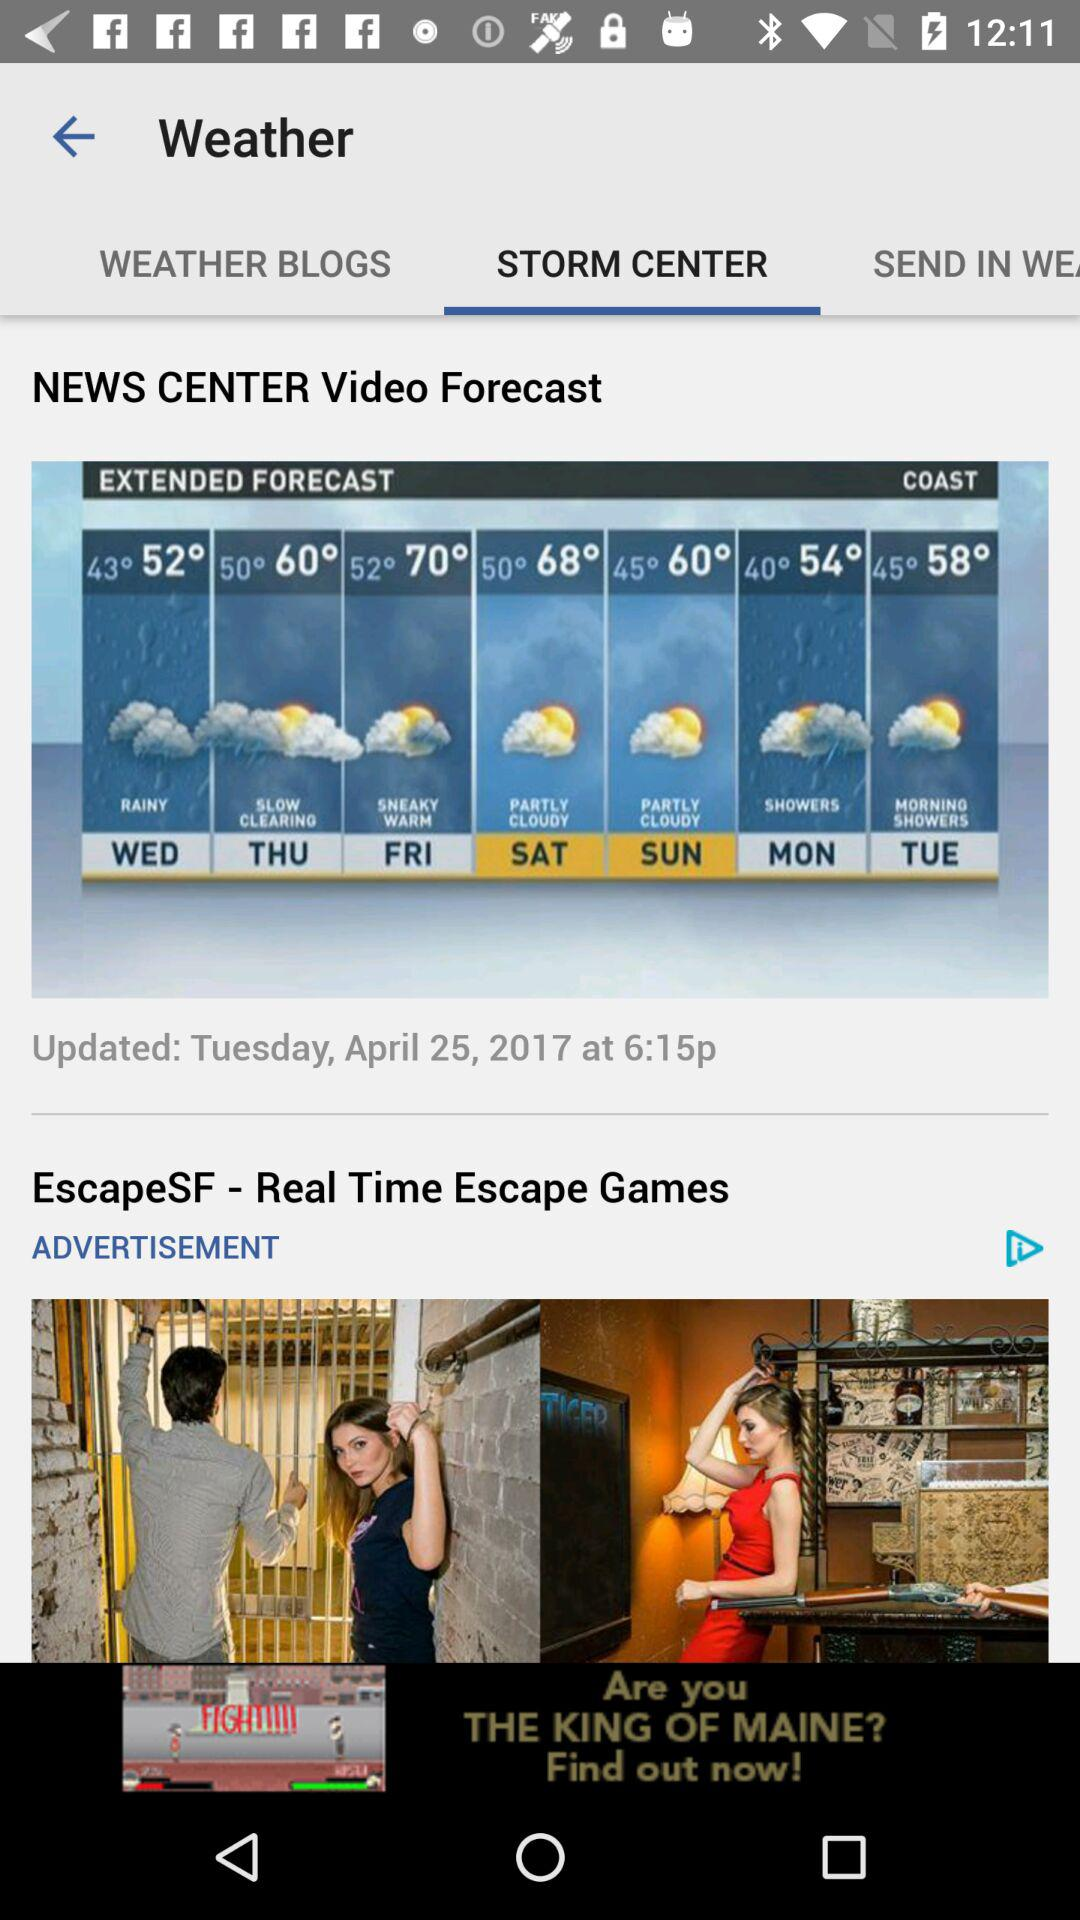Which tab is selected? The selected tab is "STORM CENTER". 